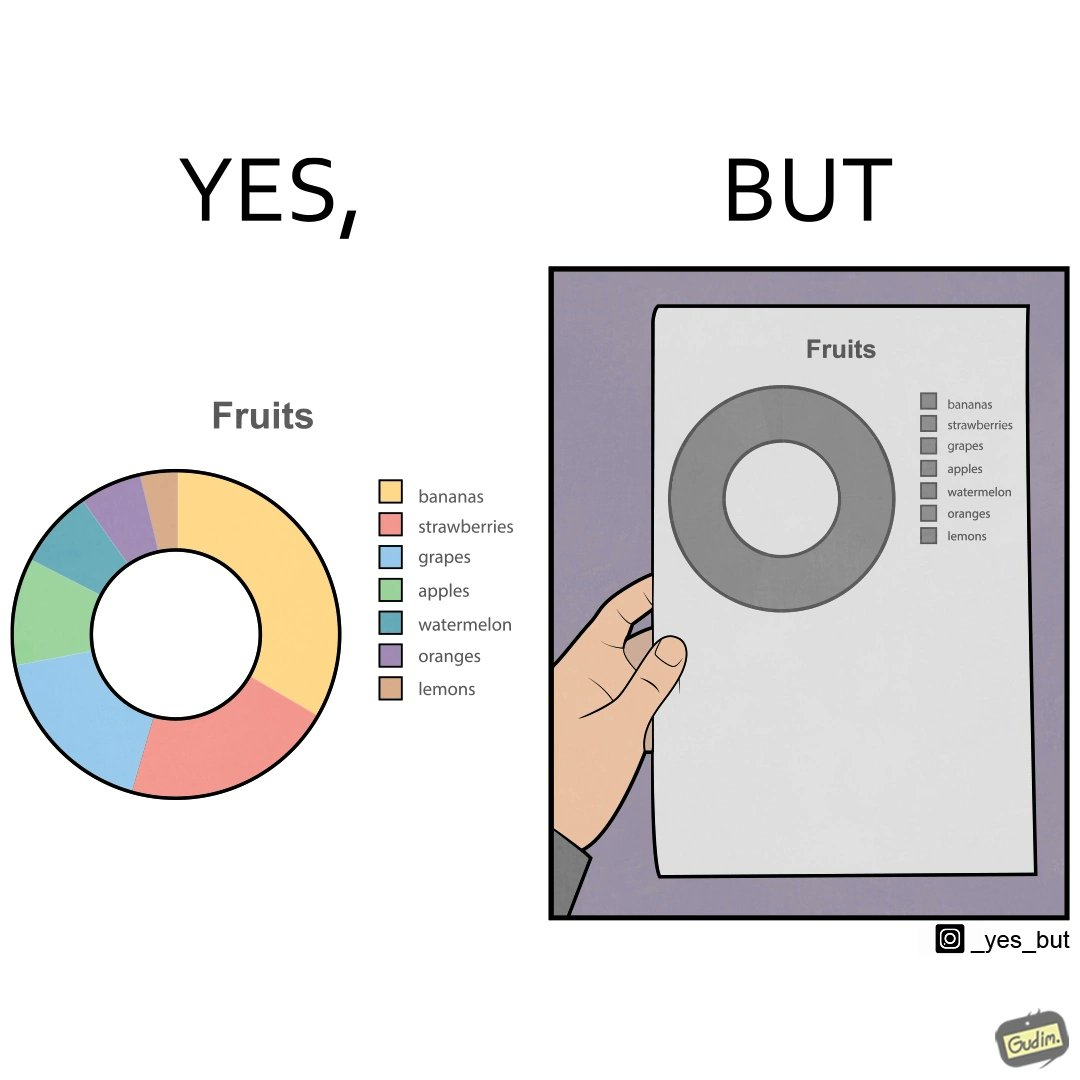Explain the humor or irony in this image. This is funny because the pie chart printout is useless as you cant see any divisions on it because the  printer could not capture the different colors 